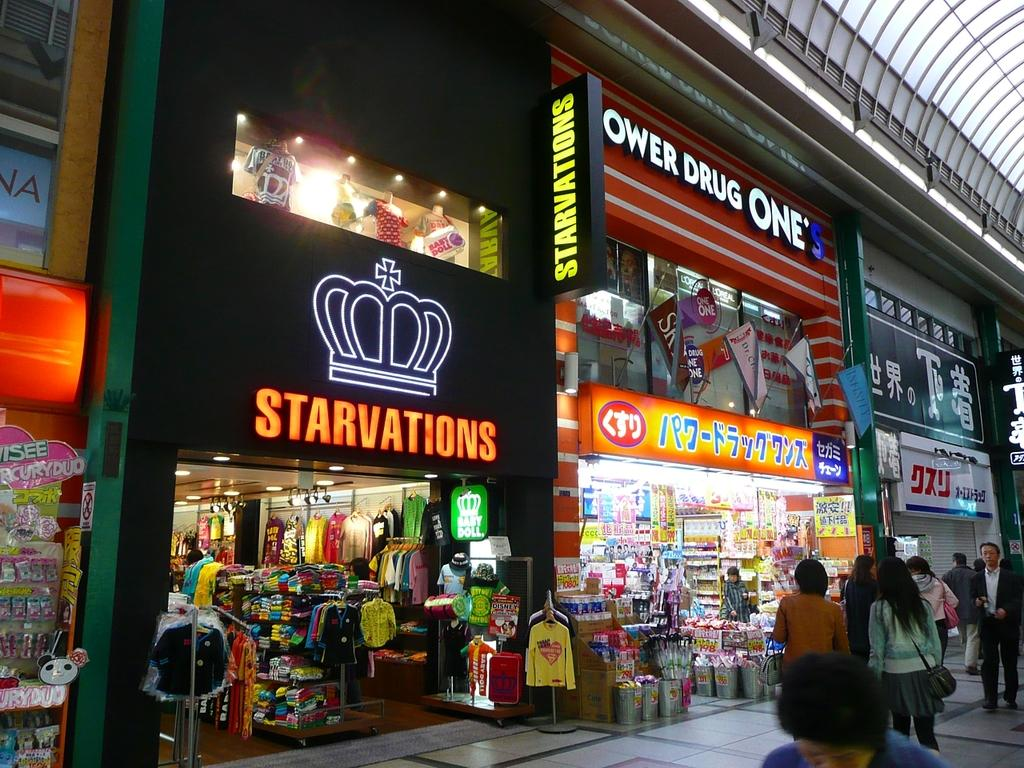Provide a one-sentence caption for the provided image. Shoppers on a street are shown in front of stores such as Starvations and Ower Drug One's. 